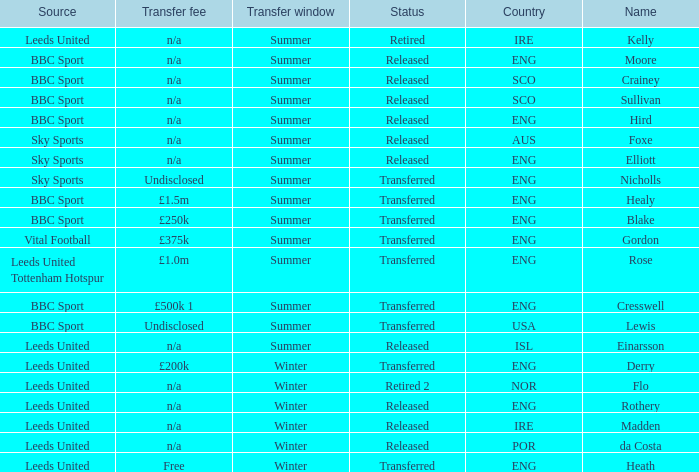What is the person's name that is from the country of SCO? Crainey, Sullivan. Could you parse the entire table as a dict? {'header': ['Source', 'Transfer fee', 'Transfer window', 'Status', 'Country', 'Name'], 'rows': [['Leeds United', 'n/a', 'Summer', 'Retired', 'IRE', 'Kelly'], ['BBC Sport', 'n/a', 'Summer', 'Released', 'ENG', 'Moore'], ['BBC Sport', 'n/a', 'Summer', 'Released', 'SCO', 'Crainey'], ['BBC Sport', 'n/a', 'Summer', 'Released', 'SCO', 'Sullivan'], ['BBC Sport', 'n/a', 'Summer', 'Released', 'ENG', 'Hird'], ['Sky Sports', 'n/a', 'Summer', 'Released', 'AUS', 'Foxe'], ['Sky Sports', 'n/a', 'Summer', 'Released', 'ENG', 'Elliott'], ['Sky Sports', 'Undisclosed', 'Summer', 'Transferred', 'ENG', 'Nicholls'], ['BBC Sport', '£1.5m', 'Summer', 'Transferred', 'ENG', 'Healy'], ['BBC Sport', '£250k', 'Summer', 'Transferred', 'ENG', 'Blake'], ['Vital Football', '£375k', 'Summer', 'Transferred', 'ENG', 'Gordon'], ['Leeds United Tottenham Hotspur', '£1.0m', 'Summer', 'Transferred', 'ENG', 'Rose'], ['BBC Sport', '£500k 1', 'Summer', 'Transferred', 'ENG', 'Cresswell'], ['BBC Sport', 'Undisclosed', 'Summer', 'Transferred', 'USA', 'Lewis'], ['Leeds United', 'n/a', 'Summer', 'Released', 'ISL', 'Einarsson'], ['Leeds United', '£200k', 'Winter', 'Transferred', 'ENG', 'Derry'], ['Leeds United', 'n/a', 'Winter', 'Retired 2', 'NOR', 'Flo'], ['Leeds United', 'n/a', 'Winter', 'Released', 'ENG', 'Rothery'], ['Leeds United', 'n/a', 'Winter', 'Released', 'IRE', 'Madden'], ['Leeds United', 'n/a', 'Winter', 'Released', 'POR', 'da Costa'], ['Leeds United', 'Free', 'Winter', 'Transferred', 'ENG', 'Heath']]} 